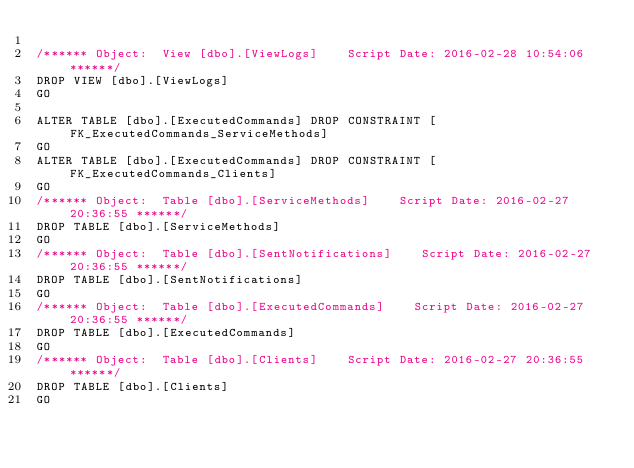Convert code to text. <code><loc_0><loc_0><loc_500><loc_500><_SQL_>
/****** Object:  View [dbo].[ViewLogs]    Script Date: 2016-02-28 10:54:06 ******/
DROP VIEW [dbo].[ViewLogs]
GO

ALTER TABLE [dbo].[ExecutedCommands] DROP CONSTRAINT [FK_ExecutedCommands_ServiceMethods]
GO
ALTER TABLE [dbo].[ExecutedCommands] DROP CONSTRAINT [FK_ExecutedCommands_Clients]
GO
/****** Object:  Table [dbo].[ServiceMethods]    Script Date: 2016-02-27 20:36:55 ******/
DROP TABLE [dbo].[ServiceMethods]
GO
/****** Object:  Table [dbo].[SentNotifications]    Script Date: 2016-02-27 20:36:55 ******/
DROP TABLE [dbo].[SentNotifications]
GO
/****** Object:  Table [dbo].[ExecutedCommands]    Script Date: 2016-02-27 20:36:55 ******/
DROP TABLE [dbo].[ExecutedCommands]
GO
/****** Object:  Table [dbo].[Clients]    Script Date: 2016-02-27 20:36:55 ******/
DROP TABLE [dbo].[Clients]
GO</code> 